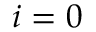<formula> <loc_0><loc_0><loc_500><loc_500>i = 0</formula> 